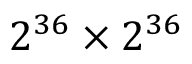<formula> <loc_0><loc_0><loc_500><loc_500>2 ^ { 3 6 } \times 2 ^ { 3 6 }</formula> 